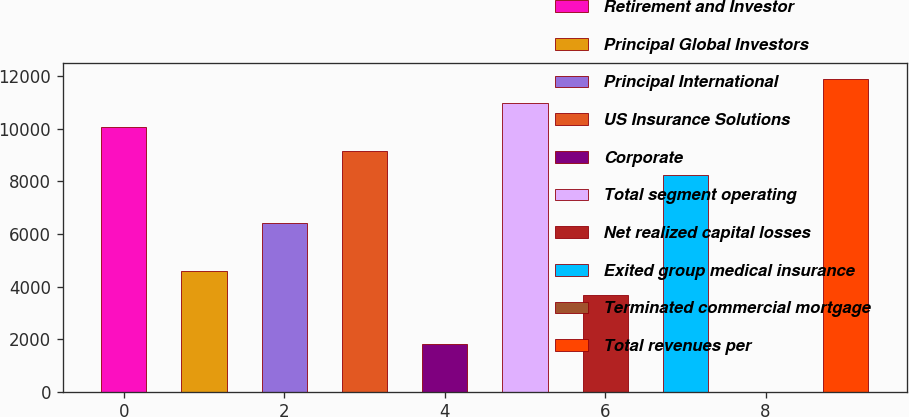Convert chart. <chart><loc_0><loc_0><loc_500><loc_500><bar_chart><fcel>Retirement and Investor<fcel>Principal Global Investors<fcel>Principal International<fcel>US Insurance Solutions<fcel>Corporate<fcel>Total segment operating<fcel>Net realized capital losses<fcel>Exited group medical insurance<fcel>Terminated commercial mortgage<fcel>Total revenues per<nl><fcel>10074.4<fcel>4579.7<fcel>6411.26<fcel>9158.6<fcel>1832.36<fcel>10990.2<fcel>3663.92<fcel>8242.82<fcel>0.8<fcel>11905.9<nl></chart> 